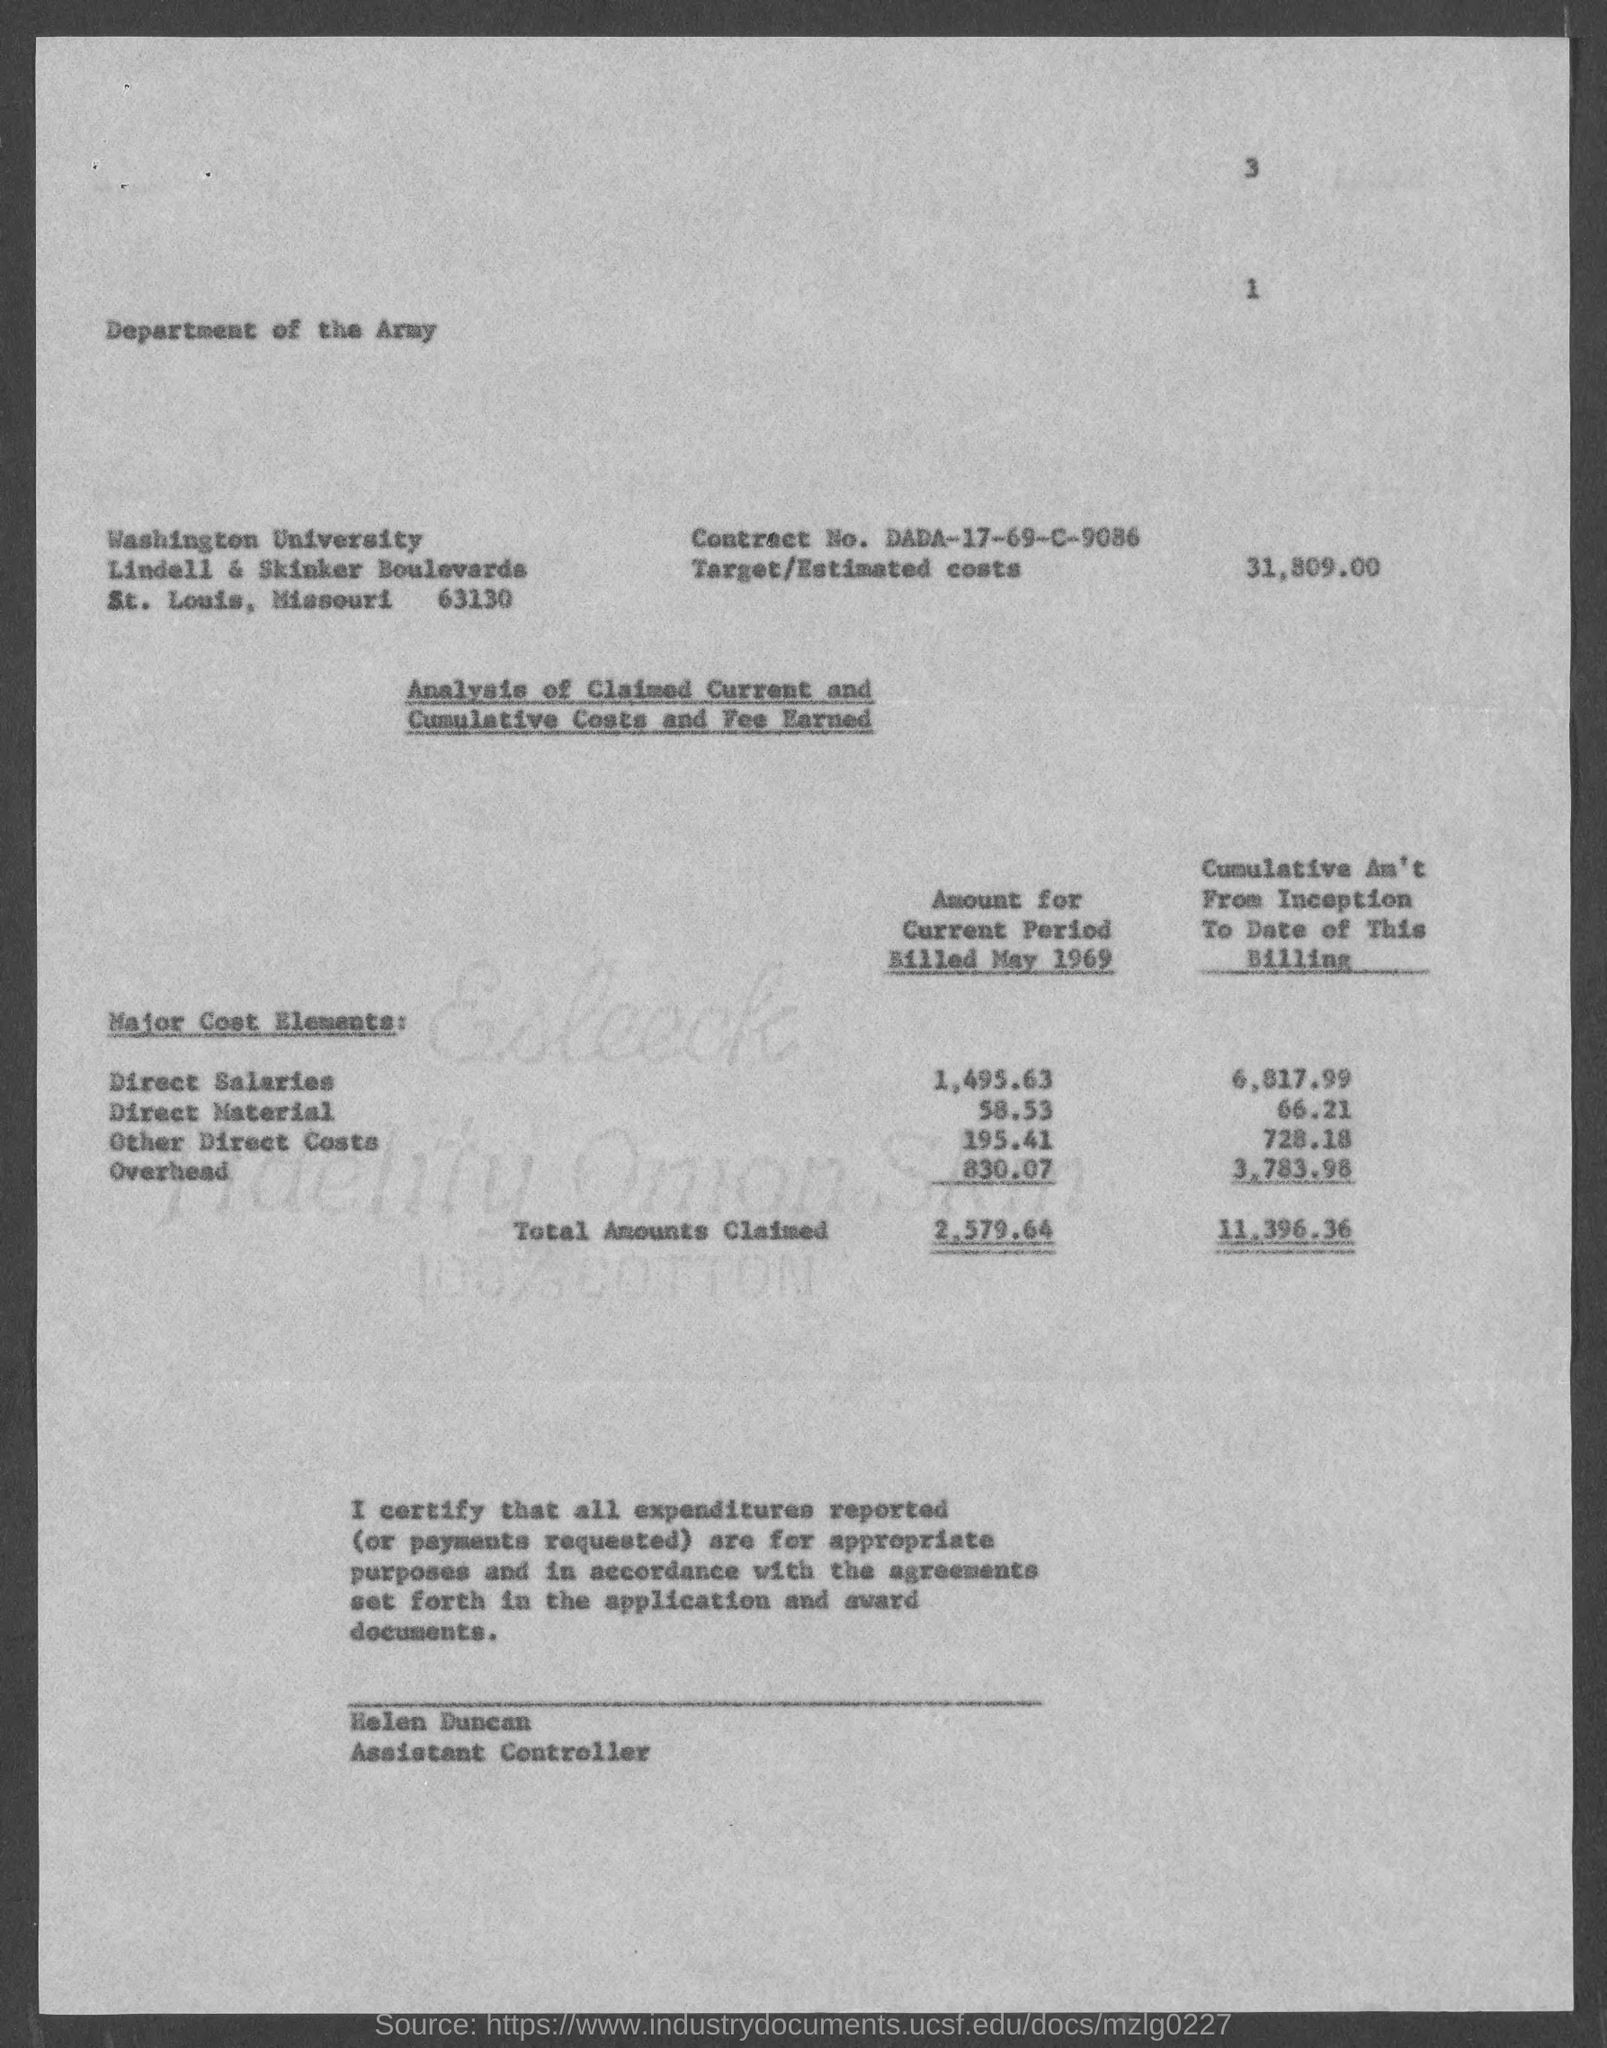Mention a couple of crucial points in this snapshot. The direct material amount billed for the current period in May 1969 was $58.53. The Contract No. given in the document is dada-17-69-c-9086. The document provides an estimated cost of 31,809. As of the date of this billing, a total of 11,396.36 has been claimed cumulatively. The direct salaries amount billed in May 1969 for the current period was $1,495.63. 